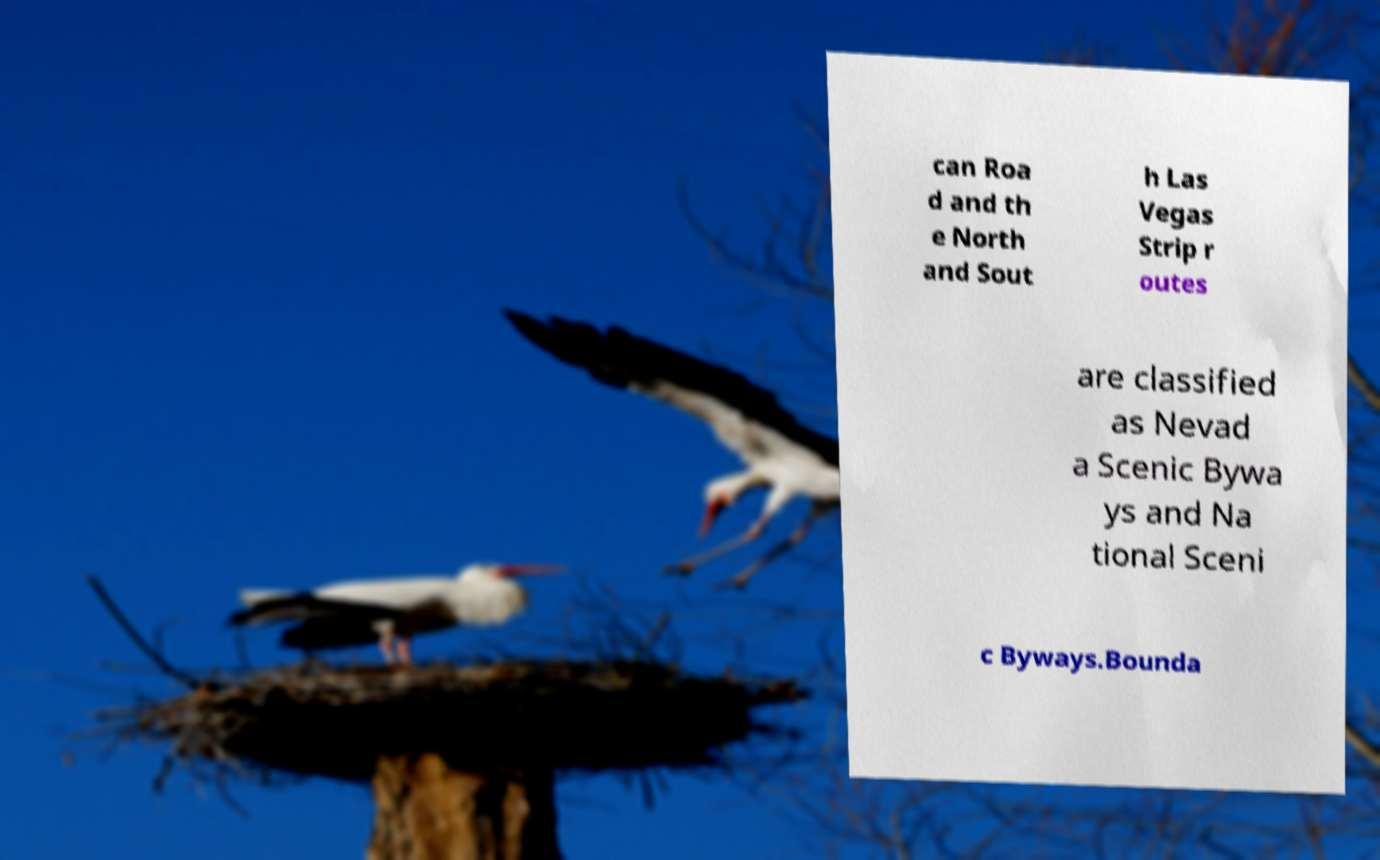Can you read and provide the text displayed in the image?This photo seems to have some interesting text. Can you extract and type it out for me? can Roa d and th e North and Sout h Las Vegas Strip r outes are classified as Nevad a Scenic Bywa ys and Na tional Sceni c Byways.Bounda 